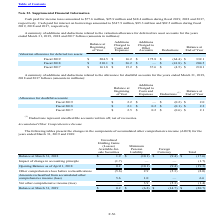From Microchip Technology's financial document, Which years does the table provide information for the additions and deductions related to the valuation allowance for deferred tax asset accounts? The document contains multiple relevant values: 2019, 2018, 2017. From the document: "on and $48.4 million during fiscal 2019, 2018 and 2017, on, $25.9 million and $48.4 million during fiscal 2019, 2018 and 2017, 5.9 million and $48.4 m..." Also, What was the balance at beginning of year in 2018? According to the financial document, 210.1 (in millions). The relevant text states: "Fiscal 2018 $ 210.1 $ 36.2 $ — $ (41.8) $ 204.5..." Also, What were the deductions in 2017? According to the financial document, (4.5) (in millions). The relevant text states: "Fiscal 2017 $ 161.8 $ 15.2 $ 37.6 $ (4.5) $ 210.1..." Also, How many years did the balance at beginning of year exceed $200 million? Counting the relevant items in the document: 2019, 2018, I find 2 instances. The key data points involved are: 2018, 2019. Also, can you calculate: What was the change in the Additions Charged to Costs and Expenses between 2017 and 2019? Based on the calculation: 175.8-37.6, the result is 138.2 (in millions). This is based on the information: "Fiscal 2017 $ 161.8 $ 15.2 $ 37.6 $ (4.5) $ 210.1 Fiscal 2019 $ 204.5 $ 16.2 $ 175.8 $ (64.4) $ 332.1..." The key data points involved are: 175.8, 37.6. Also, can you calculate: What was the percentage change in the Balance at End of Year between 2018 and 2019? To answer this question, I need to perform calculations using the financial data. The calculation is: (332.1-204.5)/204.5, which equals 62.4 (percentage). This is based on the information: "Fiscal 2019 $ 204.5 $ 16.2 $ 175.8 $ (64.4) $ 332.1 Fiscal 2019 $ 204.5 $ 16.2 $ 175.8 $ (64.4) $ 332.1..." The key data points involved are: 204.5, 332.1. 